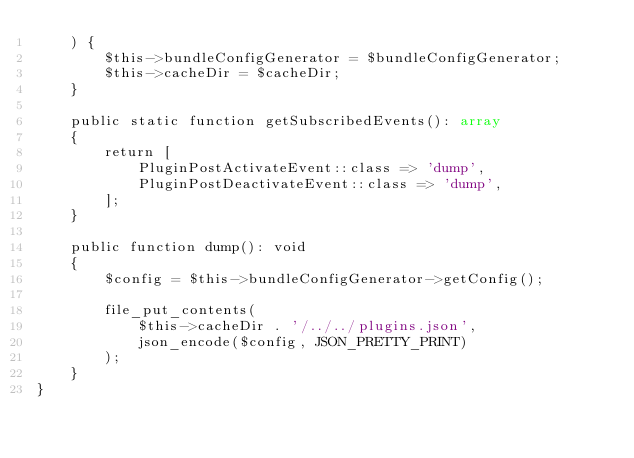Convert code to text. <code><loc_0><loc_0><loc_500><loc_500><_PHP_>    ) {
        $this->bundleConfigGenerator = $bundleConfigGenerator;
        $this->cacheDir = $cacheDir;
    }

    public static function getSubscribedEvents(): array
    {
        return [
            PluginPostActivateEvent::class => 'dump',
            PluginPostDeactivateEvent::class => 'dump',
        ];
    }

    public function dump(): void
    {
        $config = $this->bundleConfigGenerator->getConfig();

        file_put_contents(
            $this->cacheDir . '/../../plugins.json',
            json_encode($config, JSON_PRETTY_PRINT)
        );
    }
}
</code> 